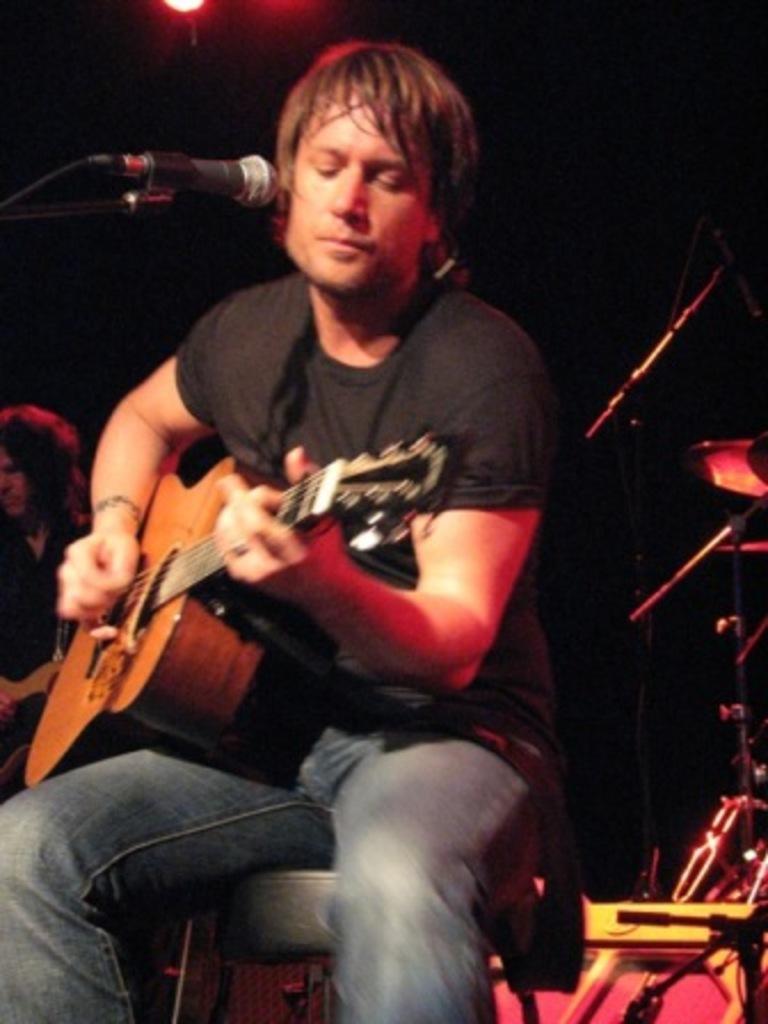Could you give a brief overview of what you see in this image? In this picture a curly haired guy is playing a guitar with a mic in front of him. There are also few musical instruments in the background and a guy playing a guitar in the background. 